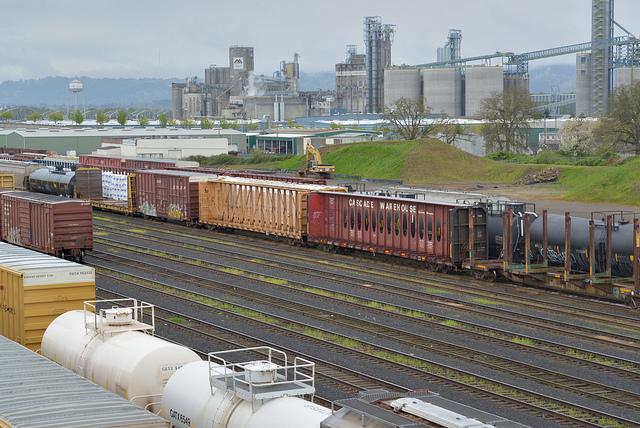What kind of building is in the background?
Answer briefly. Factory. Are there mountains in the background?
Short answer required. Yes. Is grass growing between the railroad tracks?
Quick response, please. Yes. 